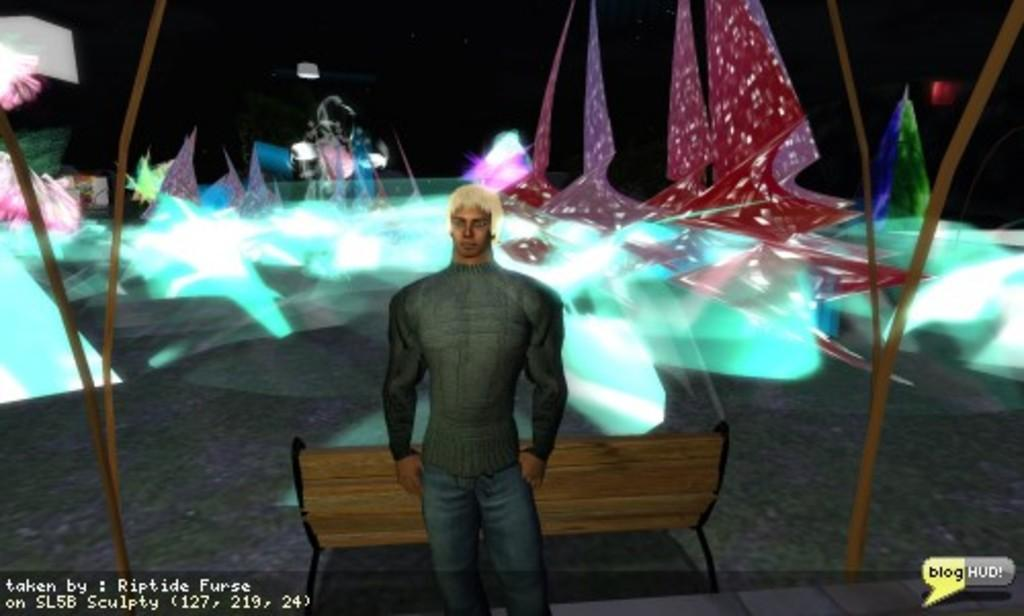What is the main subject of the image? There is a person standing in the image. What is the person standing near? There is a bench in the image. What musical instruments are visible in the image? There are drums in the image. Are there any decorative elements in the image? Yes, there are decorative items in the image. Can you describe any additional features of the image? The image has watermarks. What type of sticks are being used to play the drums in the image? There are no sticks visible in the image; the drums are not being played. What kind of pest can be seen crawling on the person in the image? There are no pests present in the image; the person appears to be alone. 